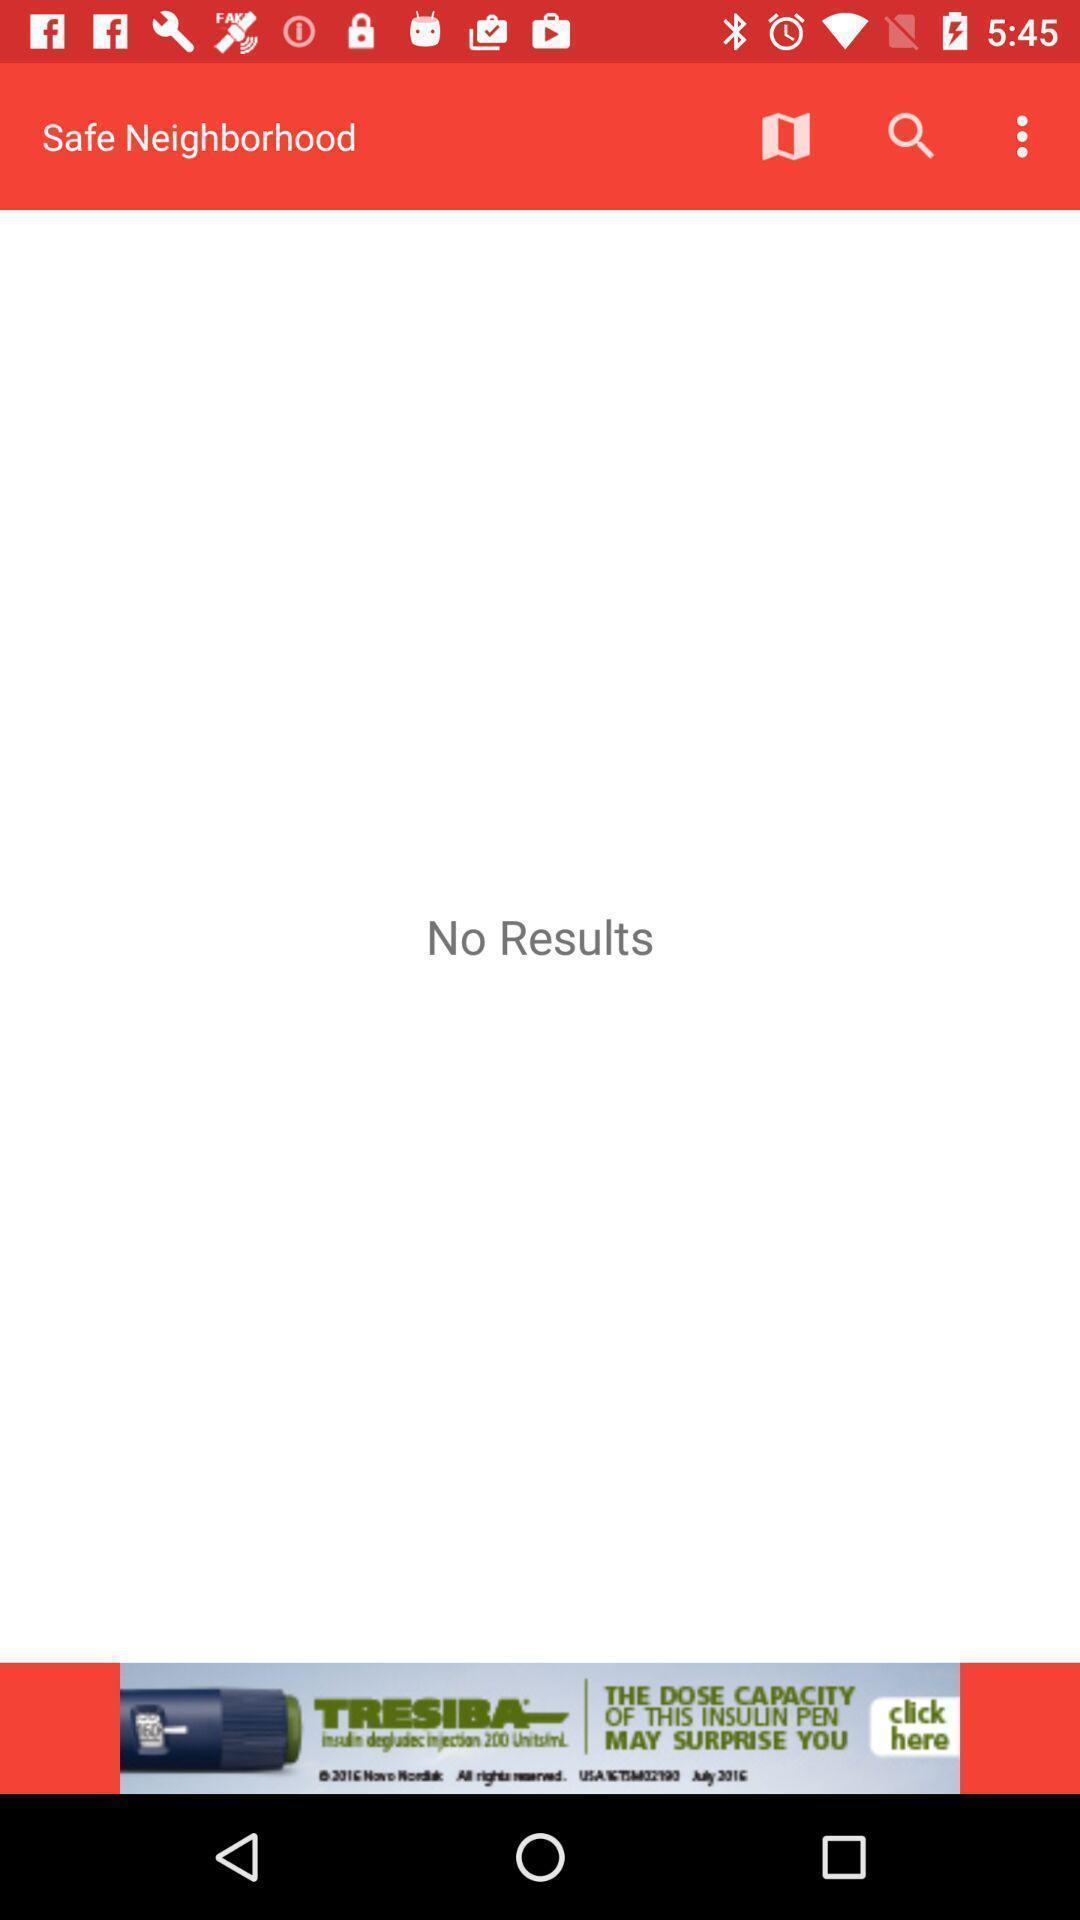Summarize the information in this screenshot. Page displaying various options like search. 